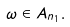<formula> <loc_0><loc_0><loc_500><loc_500>\omega \in A _ { n _ { 1 } } .</formula> 